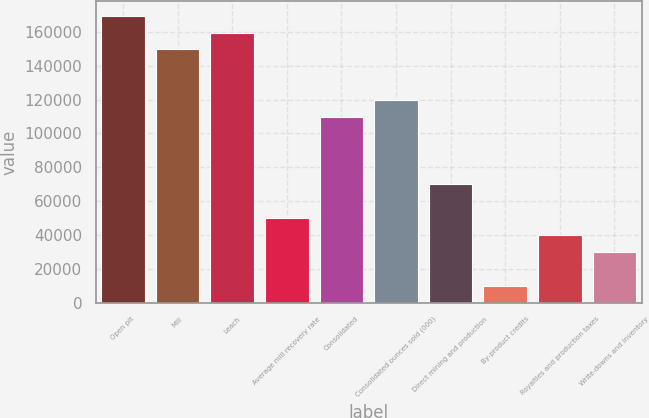Convert chart to OTSL. <chart><loc_0><loc_0><loc_500><loc_500><bar_chart><fcel>Open pit<fcel>Mill<fcel>Leach<fcel>Average mill recovery rate<fcel>Consolidated<fcel>Consolidated ounces sold (000)<fcel>Direct mining and production<fcel>By-product credits<fcel>Royalties and production taxes<fcel>Write-downs and inventory<nl><fcel>169648<fcel>149689<fcel>159669<fcel>49896.5<fcel>109772<fcel>119752<fcel>69855.1<fcel>9979.35<fcel>39917.2<fcel>29937.9<nl></chart> 